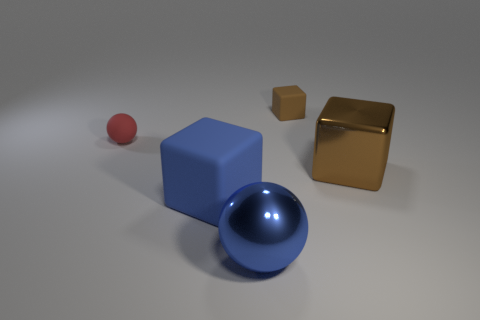Add 4 tiny red rubber spheres. How many objects exist? 9 Subtract all balls. How many objects are left? 3 Add 5 tiny brown blocks. How many tiny brown blocks are left? 6 Add 2 tiny brown blocks. How many tiny brown blocks exist? 3 Subtract 0 purple cylinders. How many objects are left? 5 Subtract all rubber things. Subtract all tiny red things. How many objects are left? 1 